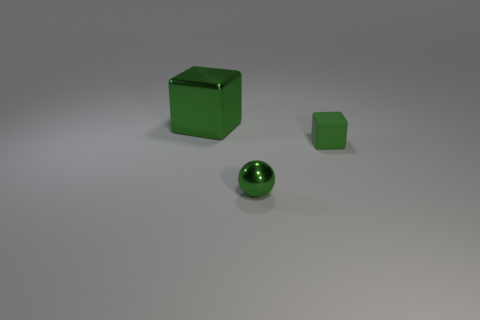Add 3 tiny blue things. How many objects exist? 6 Subtract all spheres. How many objects are left? 2 Add 3 tiny green metal balls. How many tiny green metal balls are left? 4 Add 3 matte objects. How many matte objects exist? 4 Subtract 0 red spheres. How many objects are left? 3 Subtract all spheres. Subtract all green metallic cubes. How many objects are left? 1 